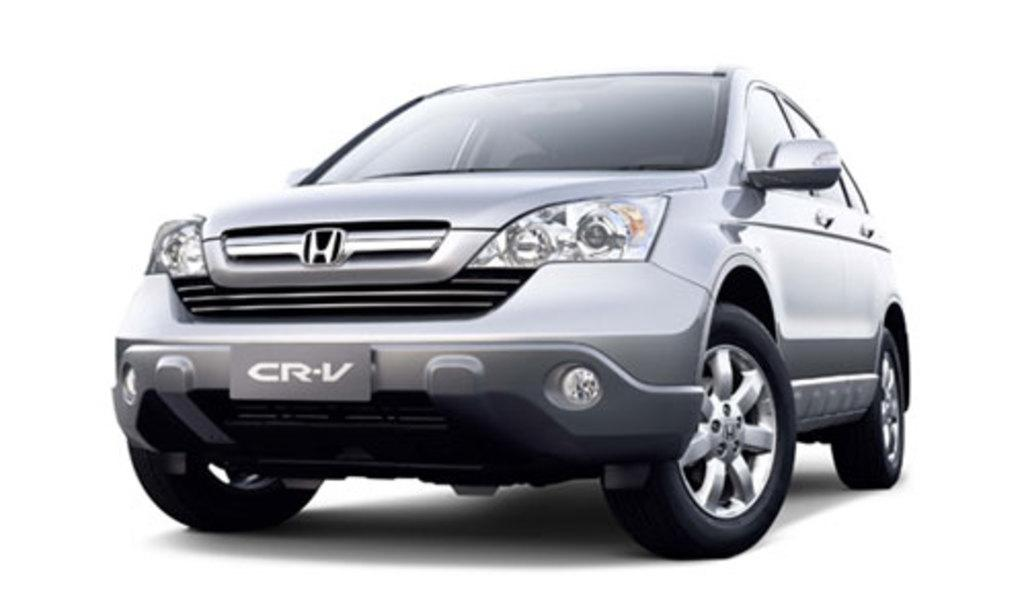What is the main subject of the image? There is a car in the center of the image. What is the color of the surface in the image? The image has a white surface. What is the color of the background in the image? The image has a white background. Can you hear the bell ringing in the image? There is no bell present in the image, so it cannot be heard. 